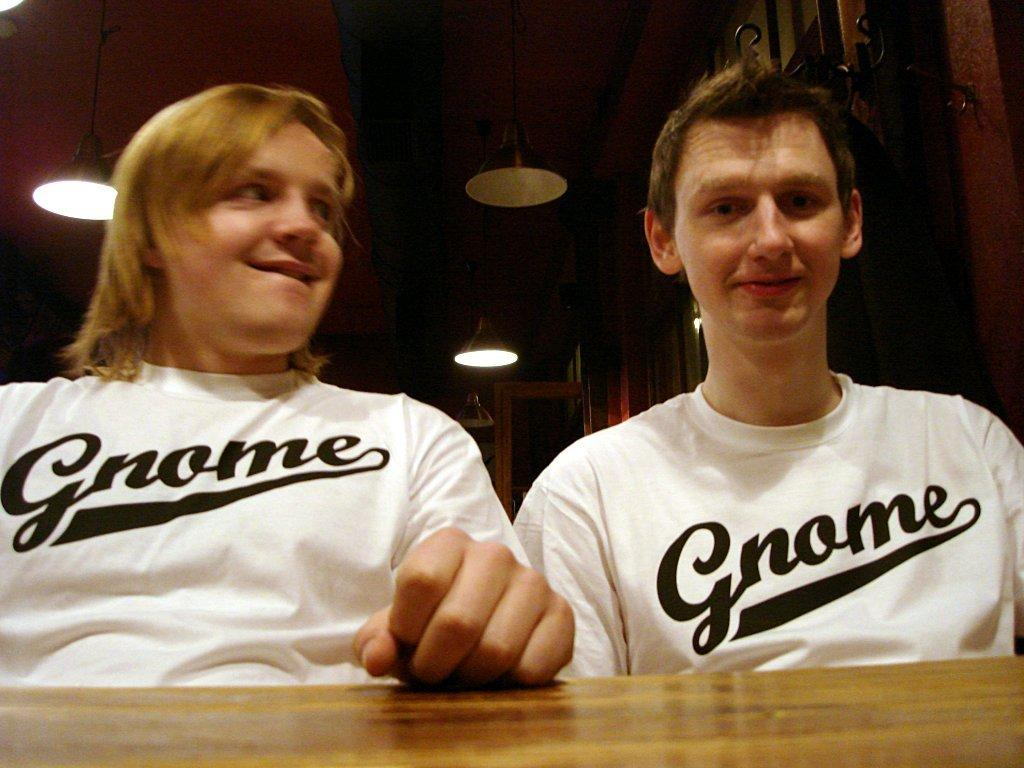<image>
Describe the image concisely. Two people sitting next to each other with white t-shirts with the word Gnome on them. 